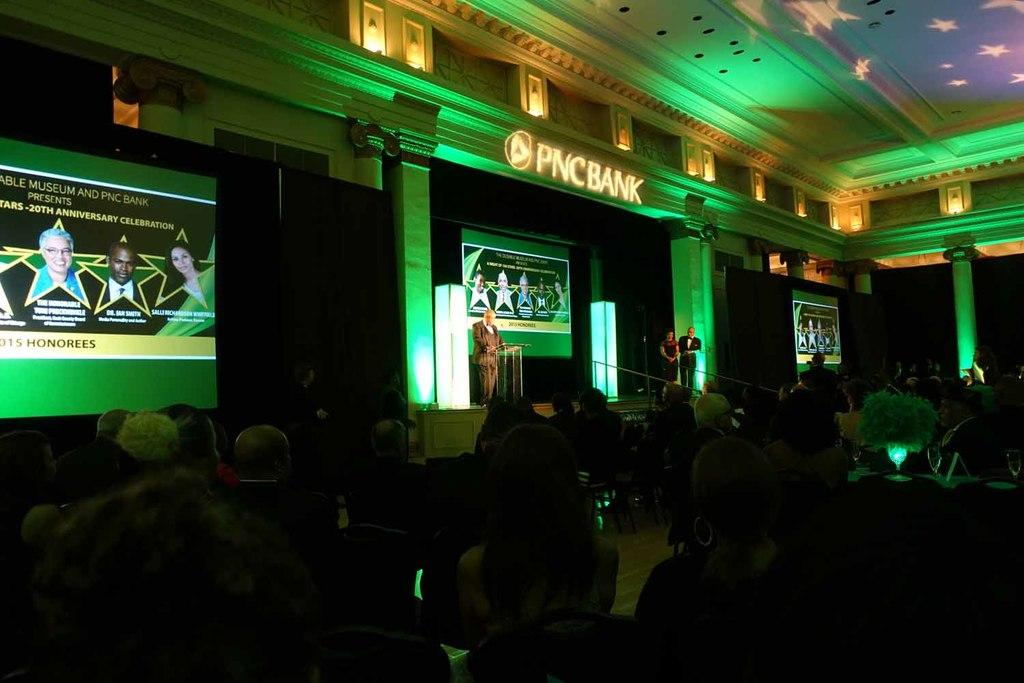What are the people in the image doing? The people in the image are sitting. Are there any standing persons in the image? Yes, there is one person standing in the image. How many persons are standing in the image? There are two persons standing in the image. What can be seen in the background of the image? There is a screen in the background of the image. What type of badge is the person wearing in the image? There is no badge visible on any person in the image. What kind of weather can be seen in the image? The image does not provide any information about the weather, as it focuses on the people and the screen in the background. 